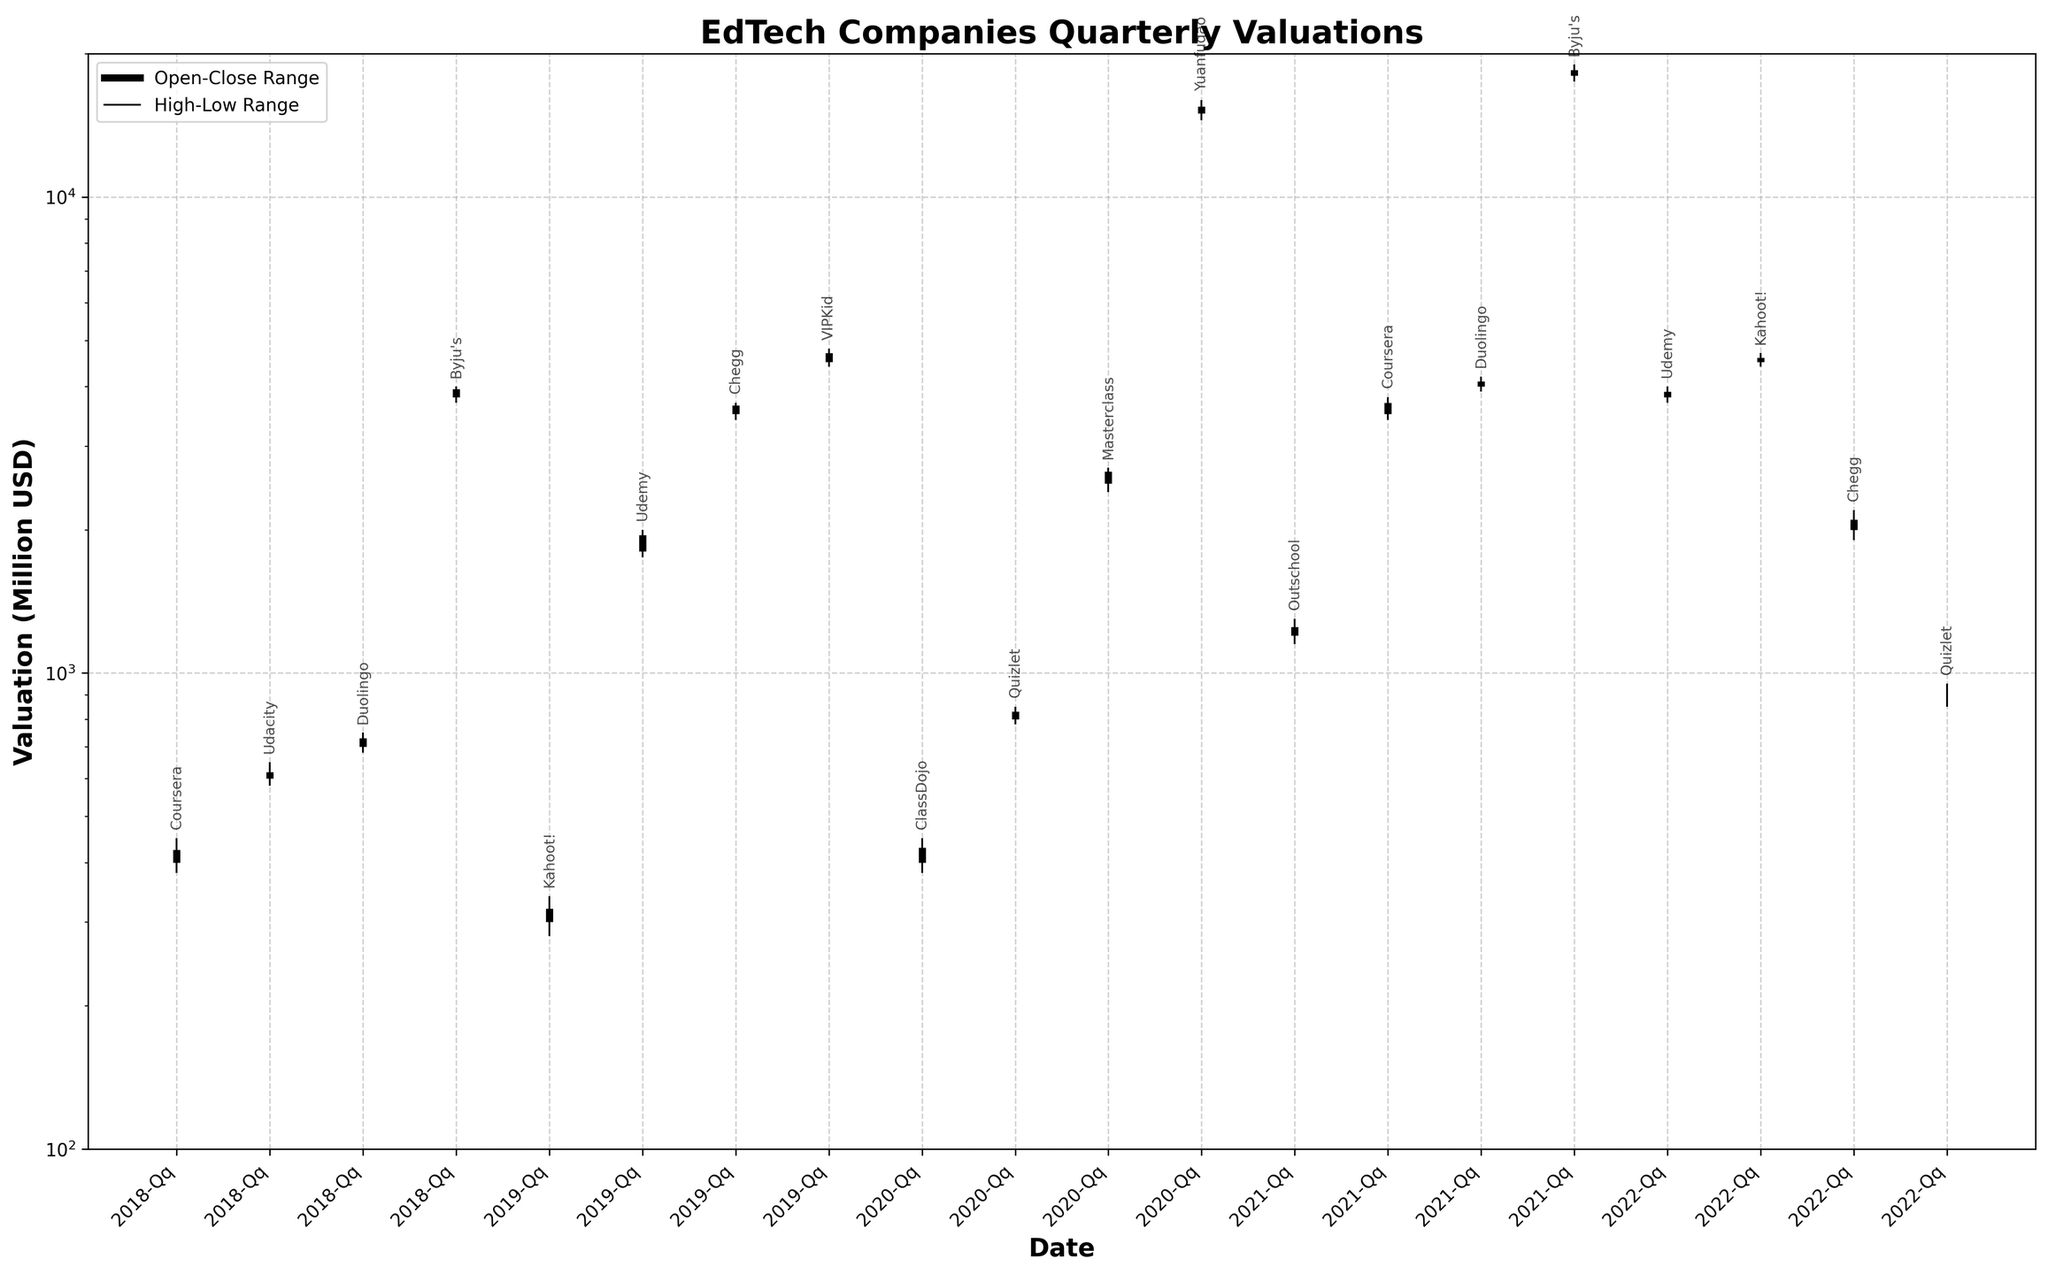What is the title of the plot? The title of the plot is located at the top and reads "EdTech Companies Quarterly Valuations."
Answer: EdTech Companies Quarterly Valuations How many time periods are represented on the x-axis? By counting the number of x-axis ticks, we see there are 19 time periods represented.
Answer: 19 Which company had the highest valuation in any quarter within the past 5 years? By observing the highest lines on the plot, Yuanfudao had the highest valuation in 2020-Q4.
Answer: Yuanfudao What is the range of valuations for ClassDojo in 2020-Q1? The range is determined by subtracting the low value from the high value: 450 - 380 = 70.
Answer: 70 How do the valuations of Coursera in 2018-Q1 compare to Coursera in 2021-Q2? Compare the open, high, low, and close values for Coursera in these two periods. Coursera's 2021-Q2 values are significantly higher than those in 2018-Q1.
Answer: Higher in 2021-Q2 What is the average of the closing valuations for Byju's across 2018-Q4 and 2021-Q4? Add the closing valuations for these two quarters and divide by 2: (3950 + 18500) / 2 = 11225.
Answer: 11225 Which company had the smallest difference between its high and low valuations within a quarter? The smallest range can be identified visually by finding the shortest vertical line between high and low. For Kahoot! in 2019-Q1, the difference is 340 - 280 = 60, which appears to be the smallest.
Answer: Kahoot! What is the overall trend for Duolingo's valuations over the quarters it appears? By observing the valuations for Duolingo in 2018-Q3, 2021-Q3, and 2022-Q3, there is a general upward trend in the valuations.
Answer: Upward Which quarters show valuations above 15000? Identify the plotted points above the 15000-mark. Only 2020-Q4 with Yuanfudao and 2021-Q4 with Byju's are above 15000.
Answer: 2020-Q4, 2021-Q4 Is there a correlation between the opening and closing valuations within each quarter? Compare the lengths of the thick black lines (representing the range between Open and Close) across different quarters to observe that they often move together, suggesting a positive correlation.
Answer: Positive correlation 